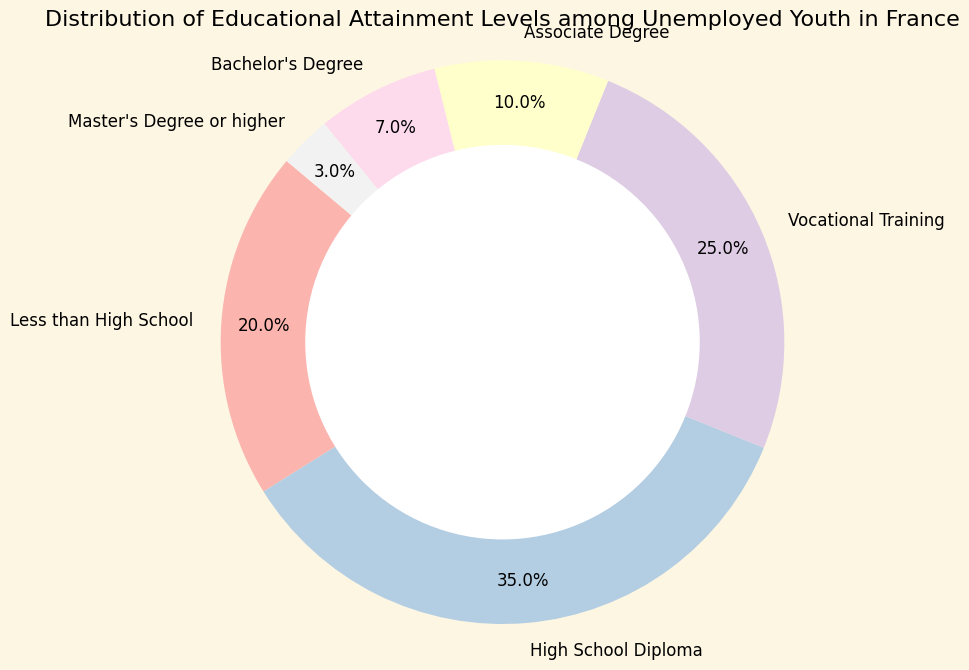How many percentage points more youth have only a high school diploma compared to those with an associate degree? The percentage of youth with a high school diploma is 35%, and those with an associate degree is 10%. Subtract 10% from 35% to find the difference in percentage points.
Answer: 25 What is the sum of the percentages of youth with vocational training and a bachelor's degree? The percentage of youth with vocational training is 25%, and with a bachelor's degree is 7%. Add these percentages together to find the sum.
Answer: 32 Which educational attainment level has the largest proportion of unemployed youth? By looking at the chart, the high school diploma segment is the largest slice of the pie.
Answer: High School Diploma Compare the percentage of youth with less than a high school education with those having a master's degree or higher. The percentage of youth with less than a high school education is 20%, and those with a master's degree or higher is 3%. 20% is greater than 3%.
Answer: Less than High School > Master's Degree or higher What percentage of unemployed youth have at least a bachelor's degree? To find the percentage of youth with at least a bachelor's degree, add the percentages of those with a bachelor's degree (7%) and a master's degree or higher (3%).
Answer: 10 What fraction of the total percentage is made up by youth with a high school diploma and those with vocational training? The percentage of youth with a high school diploma is 35%, and those with vocational training is 25%. Add these two percentages to find the combined fraction, which is 60%.
Answer: 60% Which educational attainment categories collectively make up less than 50% of the unemployed youth? Categories with percentages less than 50% collectively include "Less than High School" (20%), "Associate Degree" (10%), "Bachelor's Degree" (7%), and "Master's Degree or higher" (3%). Sum these up: 20% + 10% + 7% + 3% = 40%, which is less than 50%.
Answer: Less than High School, Associate Degree, Bachelor's Degree, Master's Degree or higher What color represents the segment for youth with a bachelor's degree? By looking at the color coding, the bachelor's degree segment is represented by its specific color in the pie chart. Assume it uses a distinct color different from the other segments.
Answer: [specific color (e.g., blue)] Is the proportion of youth with less than a high school education closer to the proportion of those with a vocational training or those with a master's degree or higher? The percentage of youth with less than a high school education is 20%. The percentage of those with vocational training is 25%, and those with a master's degree or higher is 3%. Calculate the absolute differences: 25% - 20% = 5% and 20% - 3% = 17%. Since 5% is smaller than 17%, the proportion of youth with less than a high school education is closer to those with vocational training.
Answer: Vocational Training 